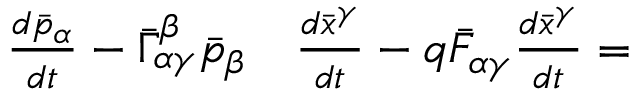Convert formula to latex. <formula><loc_0><loc_0><loc_500><loc_500>\begin{array} { r l } { { \frac { d { \bar { p } } _ { \alpha } } { d t } } - { \bar { \Gamma } } _ { \alpha \gamma } ^ { \beta } { \bar { p } } _ { \beta } } & { \frac { d { \bar { x } } ^ { \gamma } } { d t } } - q { \bar { F } } _ { \alpha \gamma } { \frac { d { \bar { x } } ^ { \gamma } } { d t } } = } \end{array}</formula> 